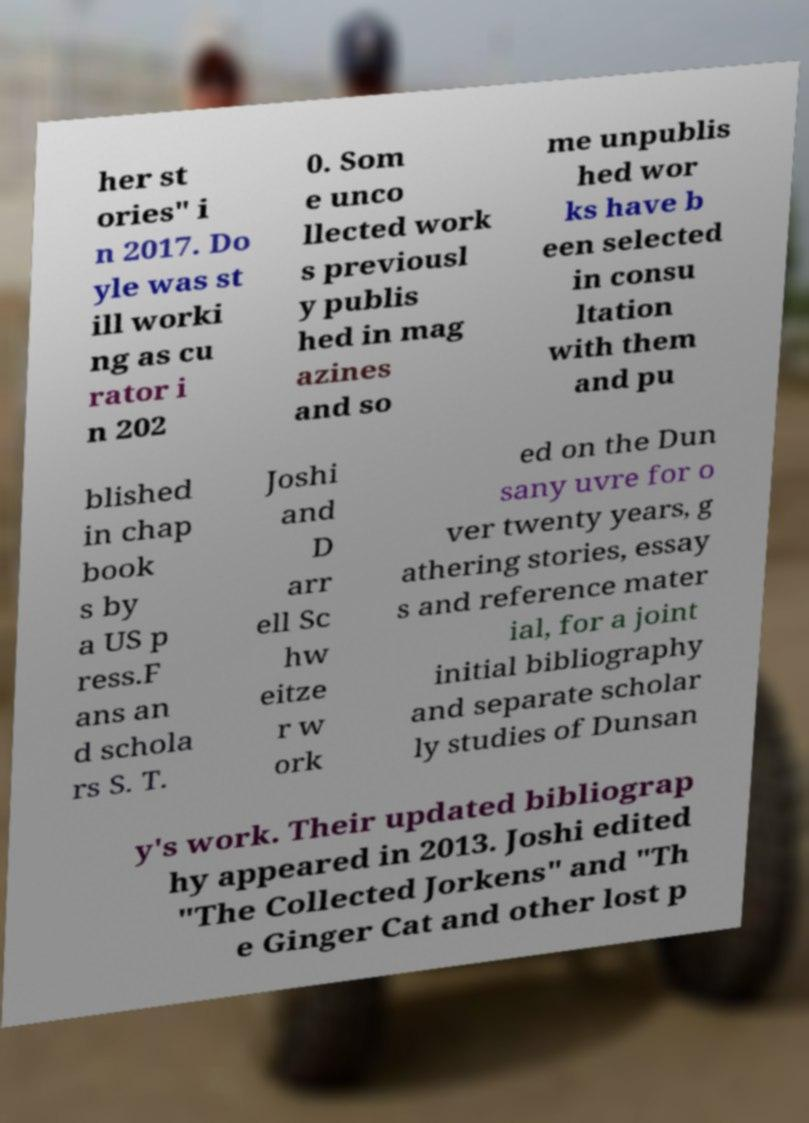What messages or text are displayed in this image? I need them in a readable, typed format. her st ories" i n 2017. Do yle was st ill worki ng as cu rator i n 202 0. Som e unco llected work s previousl y publis hed in mag azines and so me unpublis hed wor ks have b een selected in consu ltation with them and pu blished in chap book s by a US p ress.F ans an d schola rs S. T. Joshi and D arr ell Sc hw eitze r w ork ed on the Dun sany uvre for o ver twenty years, g athering stories, essay s and reference mater ial, for a joint initial bibliography and separate scholar ly studies of Dunsan y's work. Their updated bibliograp hy appeared in 2013. Joshi edited "The Collected Jorkens" and "Th e Ginger Cat and other lost p 